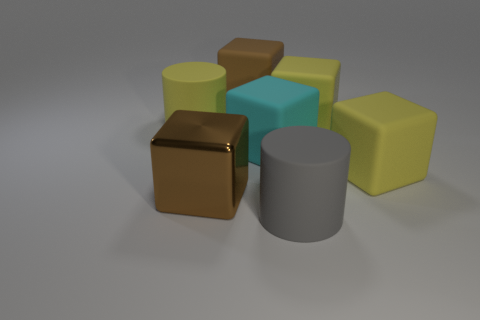Subtract all yellow cubes. How many cubes are left? 3 Subtract all cyan cubes. How many cubes are left? 4 Subtract all purple blocks. Subtract all purple spheres. How many blocks are left? 5 Add 3 yellow cylinders. How many objects exist? 10 Subtract all cylinders. How many objects are left? 5 Add 6 large yellow cubes. How many large yellow cubes exist? 8 Subtract 0 purple cubes. How many objects are left? 7 Subtract all large yellow rubber cylinders. Subtract all matte spheres. How many objects are left? 6 Add 2 brown metallic things. How many brown metallic things are left? 3 